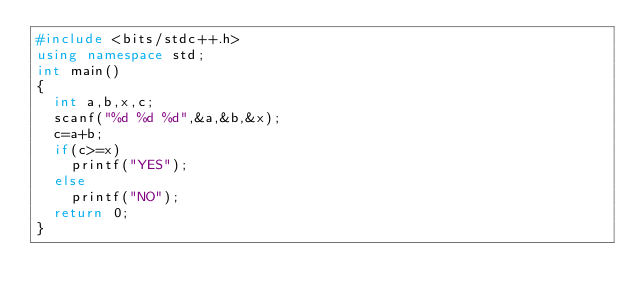<code> <loc_0><loc_0><loc_500><loc_500><_C++_>#include <bits/stdc++.h>
using namespace std;
int main()
{
	int a,b,x,c;
	scanf("%d %d %d",&a,&b,&x);
	c=a+b;
	if(c>=x)
		printf("YES");
	else
		printf("NO");
	return 0;
}</code> 